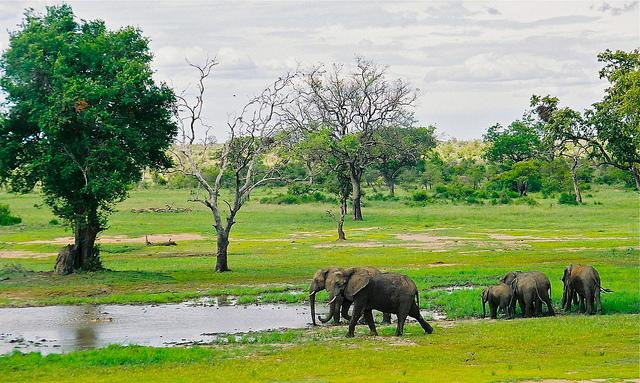What is next to the elephant? water 